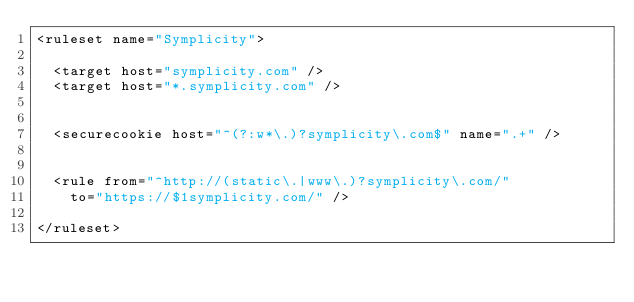<code> <loc_0><loc_0><loc_500><loc_500><_XML_><ruleset name="Symplicity">

	<target host="symplicity.com" />
	<target host="*.symplicity.com" />


	<securecookie host="^(?:w*\.)?symplicity\.com$" name=".+" />


	<rule from="^http://(static\.|www\.)?symplicity\.com/"
		to="https://$1symplicity.com/" />

</ruleset></code> 